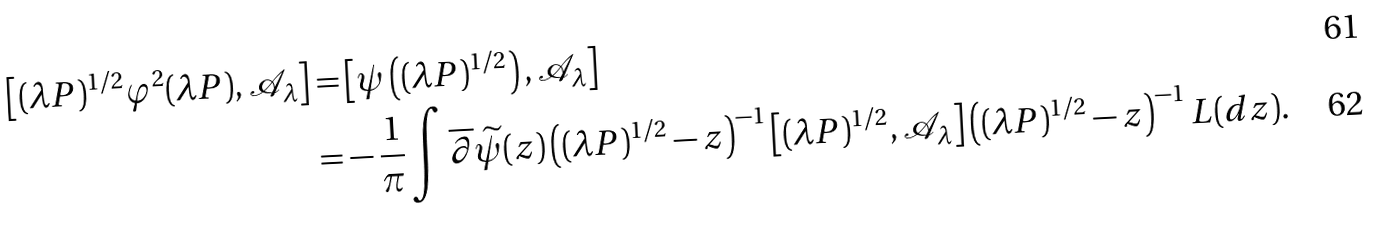<formula> <loc_0><loc_0><loc_500><loc_500>\left [ ( \lambda P ) ^ { 1 / 2 } \varphi ^ { 2 } ( \lambda P ) , { \mathcal { A } } _ { \lambda } \right ] = & \left [ \psi \left ( ( \lambda P ) ^ { 1 / 2 } \right ) , { \mathcal { A } } _ { \lambda } \right ] \\ = & - \frac { 1 } { \pi } \int \overline { \partial } \widetilde { \psi } ( z ) \left ( ( \lambda P ) ^ { 1 / 2 } - z \right ) ^ { - 1 } \left [ ( \lambda P ) ^ { 1 / 2 } , { \mathcal { A } } _ { \lambda } \right ] \left ( ( \lambda P ) ^ { 1 / 2 } - z \right ) ^ { - 1 } L ( d z ) .</formula> 